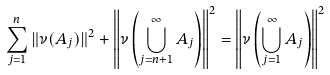<formula> <loc_0><loc_0><loc_500><loc_500>\sum _ { j = 1 } ^ { n } \| \nu ( A _ { j } ) \| ^ { 2 } + \left \| \nu \left ( \bigcup _ { j = n + 1 } ^ { \infty } A _ { j } \right ) \right \| ^ { 2 } = \left \| \nu \left ( \bigcup _ { j = 1 } ^ { \infty } A _ { j } \right ) \right \| ^ { 2 }</formula> 